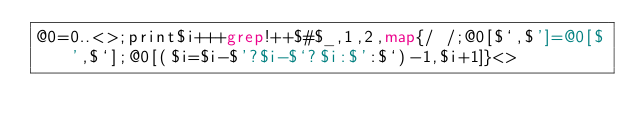<code> <loc_0><loc_0><loc_500><loc_500><_Perl_>@0=0..<>;print$i+++grep!++$#$_,1,2,map{/ /;@0[$`,$']=@0[$',$`];@0[($i=$i-$'?$i-$`?$i:$':$`)-1,$i+1]}<></code> 